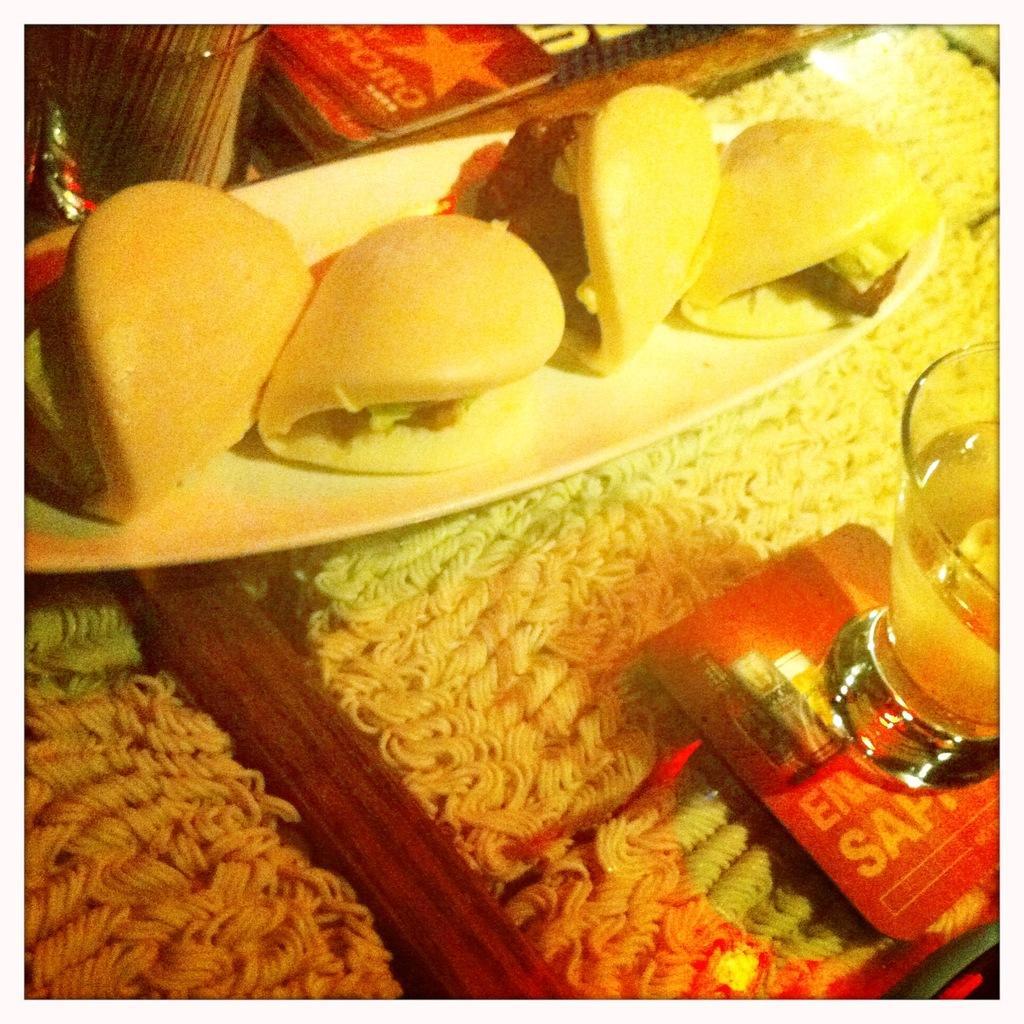How would you summarize this image in a sentence or two? Here we can see noodles, carbs, glasses, plate and food. 